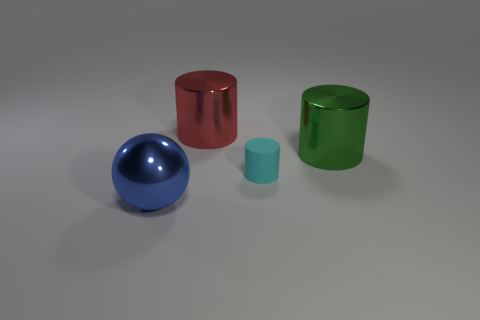Is there a large yellow thing?
Your answer should be very brief. No. Do the object in front of the small matte thing and the small cyan thing have the same material?
Offer a very short reply. No. How many blue balls have the same size as the red cylinder?
Keep it short and to the point. 1. Is the number of green shiny things that are on the left side of the green shiny thing the same as the number of large balls?
Make the answer very short. No. How many cylinders are both behind the big green cylinder and right of the large red cylinder?
Keep it short and to the point. 0. There is a red cylinder that is the same material as the large blue object; what size is it?
Your response must be concise. Large. How many other metal things are the same shape as the big blue metal thing?
Ensure brevity in your answer.  0. Are there more big red cylinders that are in front of the large green metal thing than green cylinders?
Provide a short and direct response. No. What shape is the big metallic object that is both left of the small cyan rubber cylinder and right of the blue thing?
Keep it short and to the point. Cylinder. Is the cyan rubber cylinder the same size as the blue shiny sphere?
Give a very brief answer. No. 